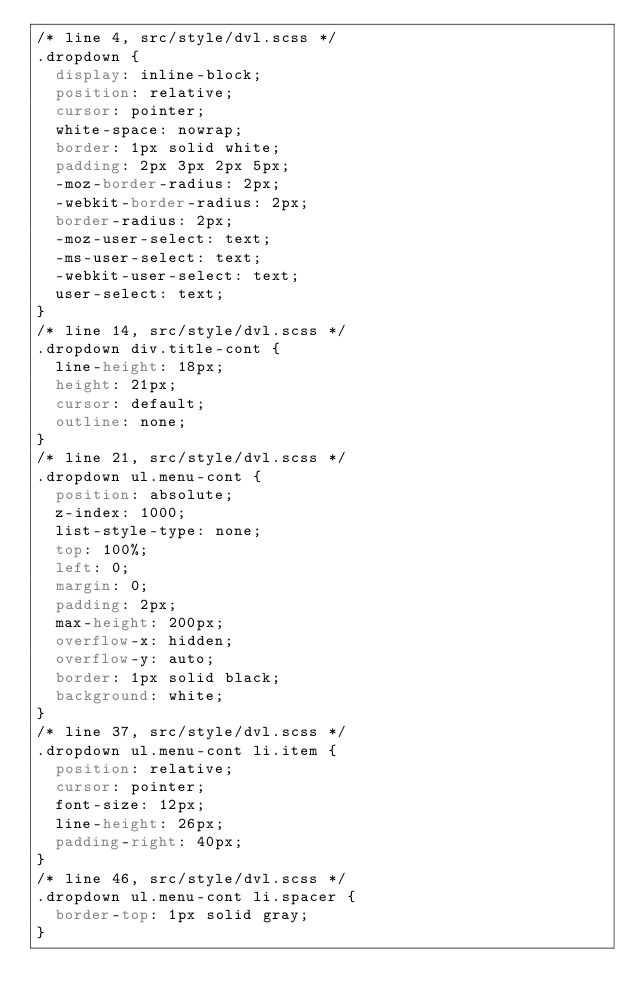<code> <loc_0><loc_0><loc_500><loc_500><_CSS_>/* line 4, src/style/dvl.scss */
.dropdown {
  display: inline-block;
  position: relative;
  cursor: pointer;
  white-space: nowrap;
  border: 1px solid white;
  padding: 2px 3px 2px 5px;
  -moz-border-radius: 2px;
  -webkit-border-radius: 2px;
  border-radius: 2px;
  -moz-user-select: text;
  -ms-user-select: text;
  -webkit-user-select: text;
  user-select: text;
}
/* line 14, src/style/dvl.scss */
.dropdown div.title-cont {
  line-height: 18px;
  height: 21px;
  cursor: default;
  outline: none;
}
/* line 21, src/style/dvl.scss */
.dropdown ul.menu-cont {
  position: absolute;
  z-index: 1000;
  list-style-type: none;
  top: 100%;
  left: 0;
  margin: 0;
  padding: 2px;
  max-height: 200px;
  overflow-x: hidden;
  overflow-y: auto;
  border: 1px solid black;
  background: white;
}
/* line 37, src/style/dvl.scss */
.dropdown ul.menu-cont li.item {
  position: relative;
  cursor: pointer;
  font-size: 12px;
  line-height: 26px;
  padding-right: 40px;
}
/* line 46, src/style/dvl.scss */
.dropdown ul.menu-cont li.spacer {
  border-top: 1px solid gray;
}
</code> 